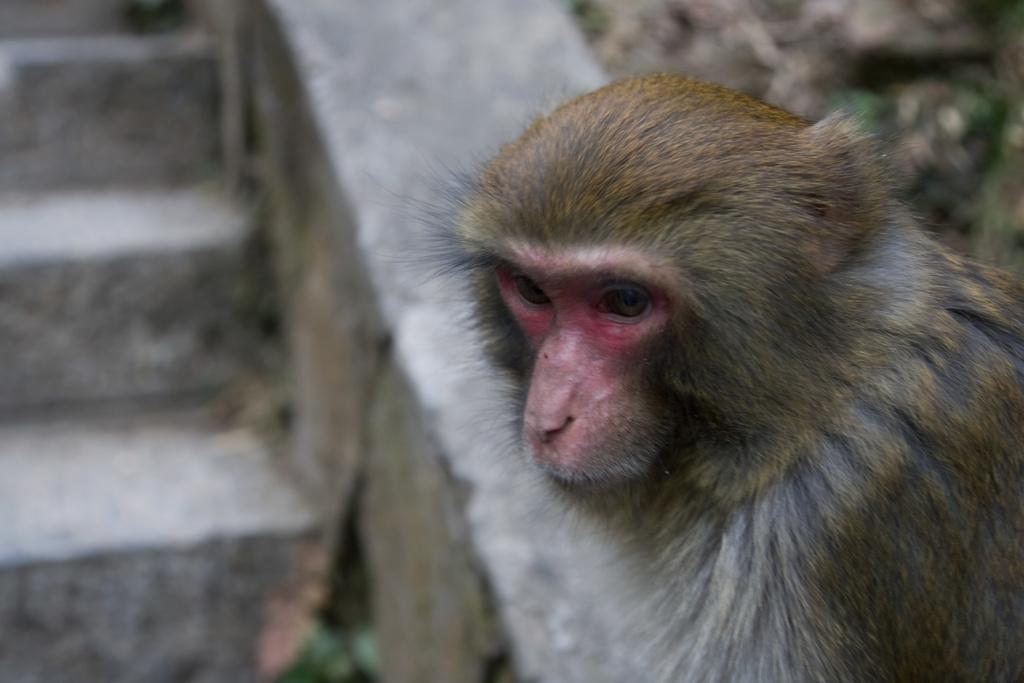What animal is on the right side of the image? There is a monkey on the right side of the image. What structure is on the left side of the image? There is a staircase on the left side of the image. What type of vegetation is present in the image? There is a plant and grass on the ground in the image. What type of veil is the dad wearing in the image? There is no dad or veil present in the image. How many drops of water can be seen falling from the monkey in the image? There are no drops of water visible in the image; it is not raining or wet. 